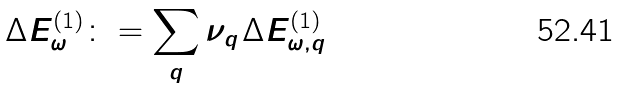<formula> <loc_0><loc_0><loc_500><loc_500>\Delta E _ { \omega } ^ { \left ( 1 \right ) } \colon = \sum _ { q } \nu _ { q \, } \Delta E _ { \omega , { q } } ^ { \left ( 1 \right ) }</formula> 